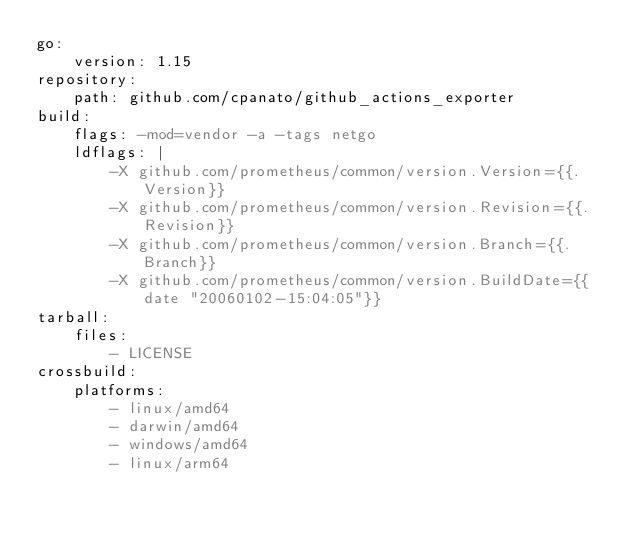Convert code to text. <code><loc_0><loc_0><loc_500><loc_500><_YAML_>go:
    version: 1.15
repository:
    path: github.com/cpanato/github_actions_exporter
build:
    flags: -mod=vendor -a -tags netgo
    ldflags: |
        -X github.com/prometheus/common/version.Version={{.Version}}
        -X github.com/prometheus/common/version.Revision={{.Revision}}
        -X github.com/prometheus/common/version.Branch={{.Branch}}
        -X github.com/prometheus/common/version.BuildDate={{date "20060102-15:04:05"}}
tarball:
    files:
        - LICENSE
crossbuild:
    platforms:
        - linux/amd64
        - darwin/amd64
        - windows/amd64
        - linux/arm64
</code> 